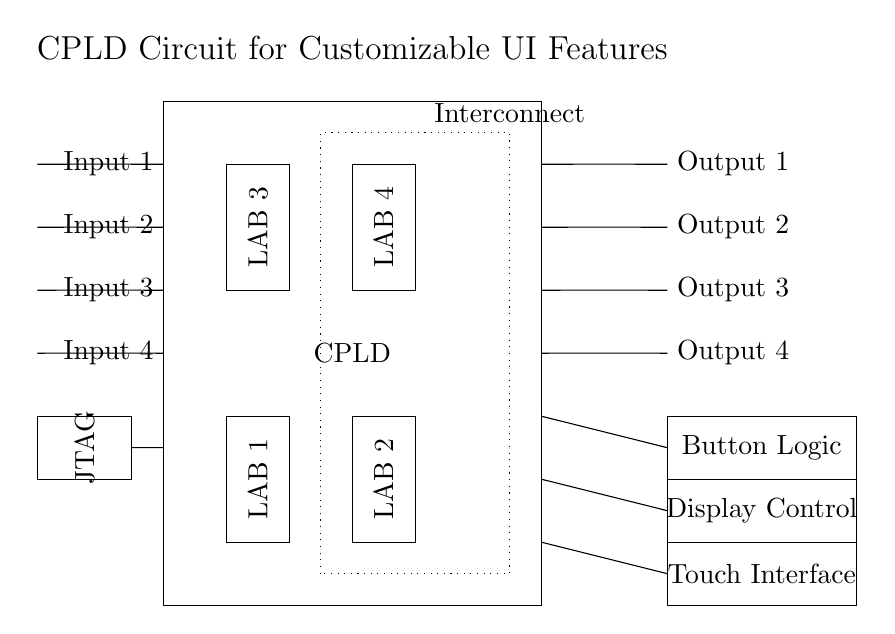What type of logic blocks are present in this circuit? The circuit contains Logic Array Blocks, specifically four labeled LAB 1, LAB 2, LAB 3, and LAB 4. These are essential elements in the CPLD for implementing custom logic functions.
Answer: Logic Array Blocks How many input pins does the CPLD have? There are four input pins indicated on the left side of the circuit diagram labeled Input 1, Input 2, Input 3, and Input 4.
Answer: Four input pins What is the purpose of the JTAG interface in this circuit? The JTAG interface is used for programming and debugging the CPLD, allowing for configuration and real-time analysis of the device's functionality.
Answer: Programming and debugging Which UI feature corresponds to Output 2? The output labeled Display Control is connected to Output 2, indicating its role in managing the display functionality of the user interface.
Answer: Display Control How are the interconnects represented in this circuit? The interconnects are represented as a dotted rectangle surrounding the Logic Array Blocks, indicating the pathways used for communication between them within the CPLD.
Answer: Dotted rectangle Why is it important to have customizable user interface features in this circuit? Customizable user interface features allow for tailoring the functionality and experience of the device according to user needs, which enhances usability and adaptability of the system.
Answer: User adaptability What is the configuration of the Touch Interface in relation to the outputs? The Touch Interface is the third UI feature listed and connects to the lowest output, Output 3, indicating its role in sensing user touch inputs directly linked to the outputs of the CPLD.
Answer: Output 3 